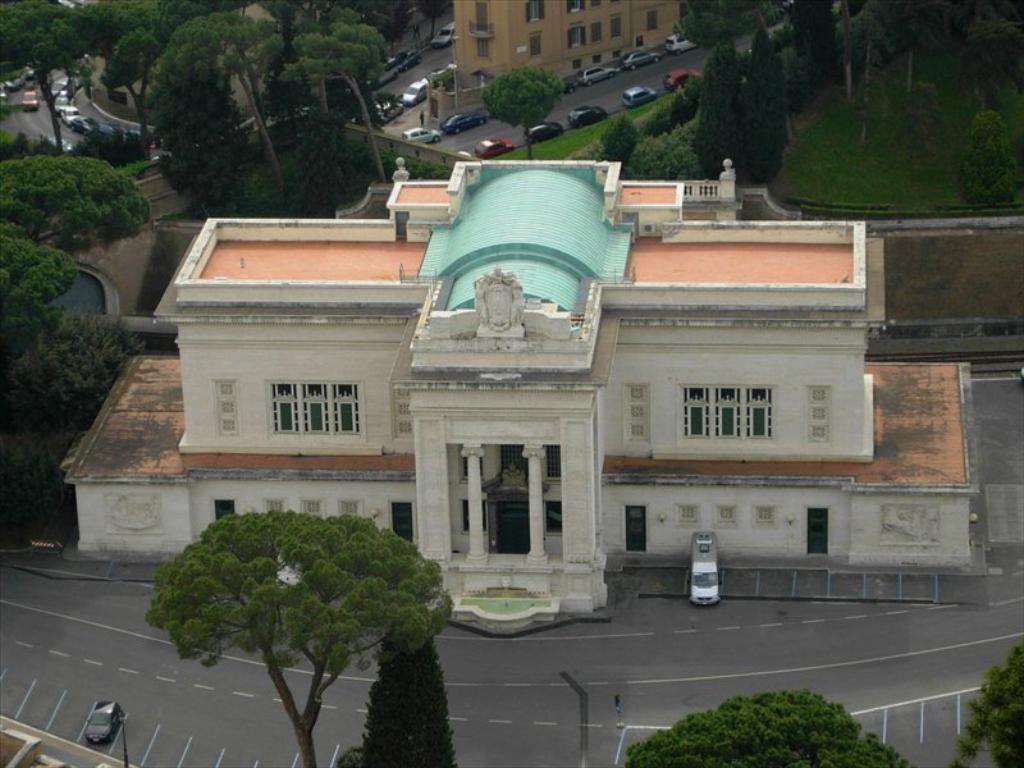Describe this image in one or two sentences. In this image we can see buildings, there are vehicles on the road, there are poles, trees, also we can see the grass. 